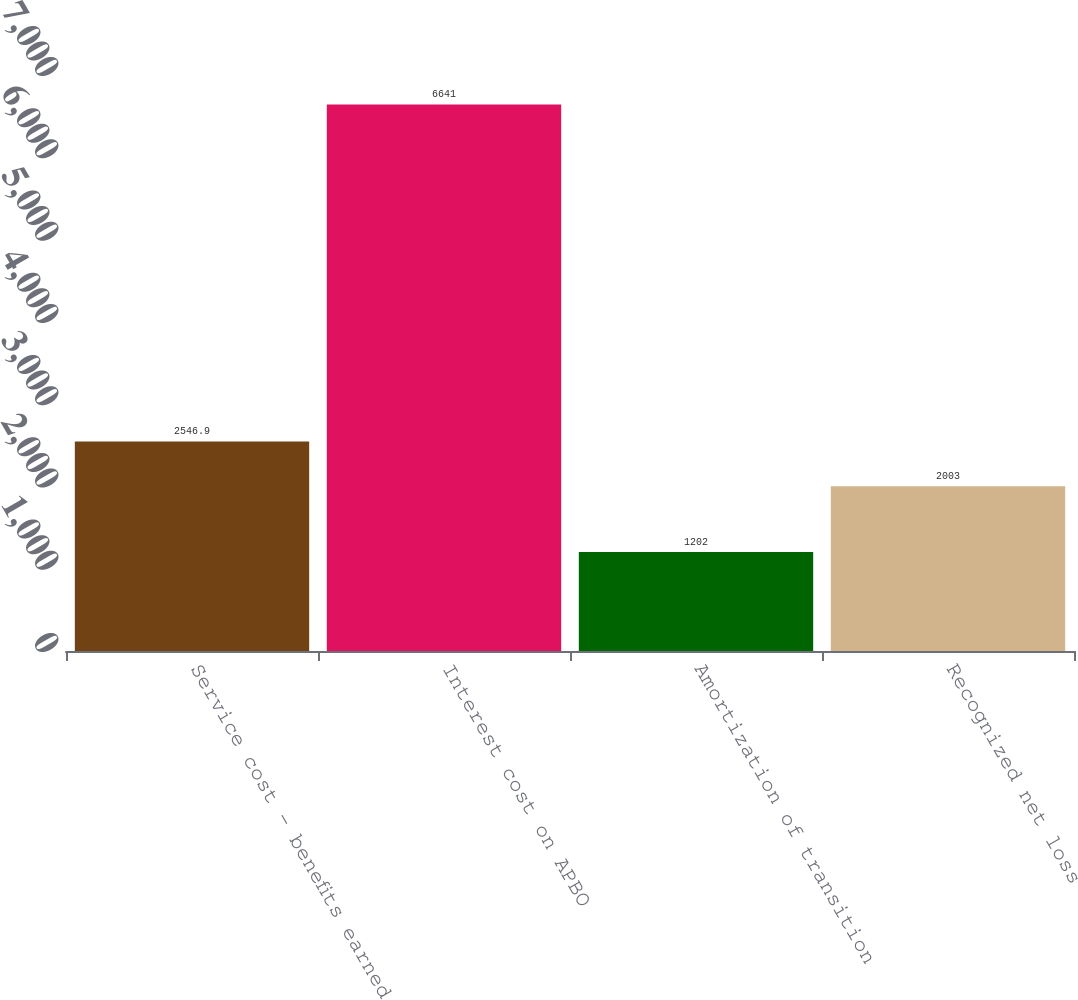<chart> <loc_0><loc_0><loc_500><loc_500><bar_chart><fcel>Service cost - benefits earned<fcel>Interest cost on APBO<fcel>Amortization of transition<fcel>Recognized net loss<nl><fcel>2546.9<fcel>6641<fcel>1202<fcel>2003<nl></chart> 